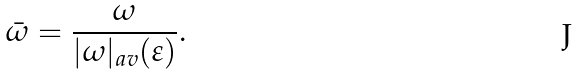<formula> <loc_0><loc_0><loc_500><loc_500>\bar { \omega } = \frac { \omega } { | \omega | _ { a v } ( \varepsilon ) } .</formula> 